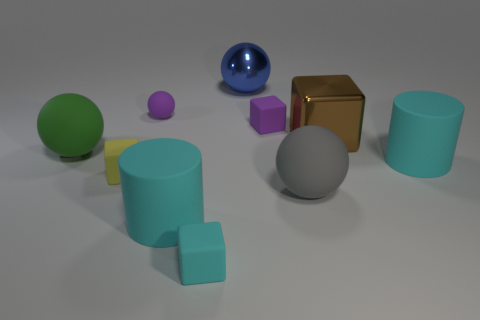The other small rubber thing that is the same shape as the blue thing is what color?
Your answer should be compact. Purple. There is a cylinder behind the large gray matte thing; is there a big rubber cylinder that is in front of it?
Provide a succinct answer. Yes. Does the object that is to the right of the brown block have the same material as the large blue object?
Ensure brevity in your answer.  No. What number of other objects are the same color as the large cube?
Ensure brevity in your answer.  0. There is a green ball that is in front of the large sphere that is behind the tiny purple cube; what size is it?
Make the answer very short. Large. Does the big cyan cylinder that is on the right side of the cyan matte cube have the same material as the large brown thing that is behind the small yellow thing?
Ensure brevity in your answer.  No. Is the color of the tiny object to the right of the small cyan matte thing the same as the tiny sphere?
Ensure brevity in your answer.  Yes. There is a blue metal ball; how many small cyan cubes are in front of it?
Make the answer very short. 1. Do the blue sphere and the brown block that is right of the big gray matte sphere have the same material?
Offer a very short reply. Yes. The purple thing that is made of the same material as the purple cube is what size?
Provide a succinct answer. Small. 